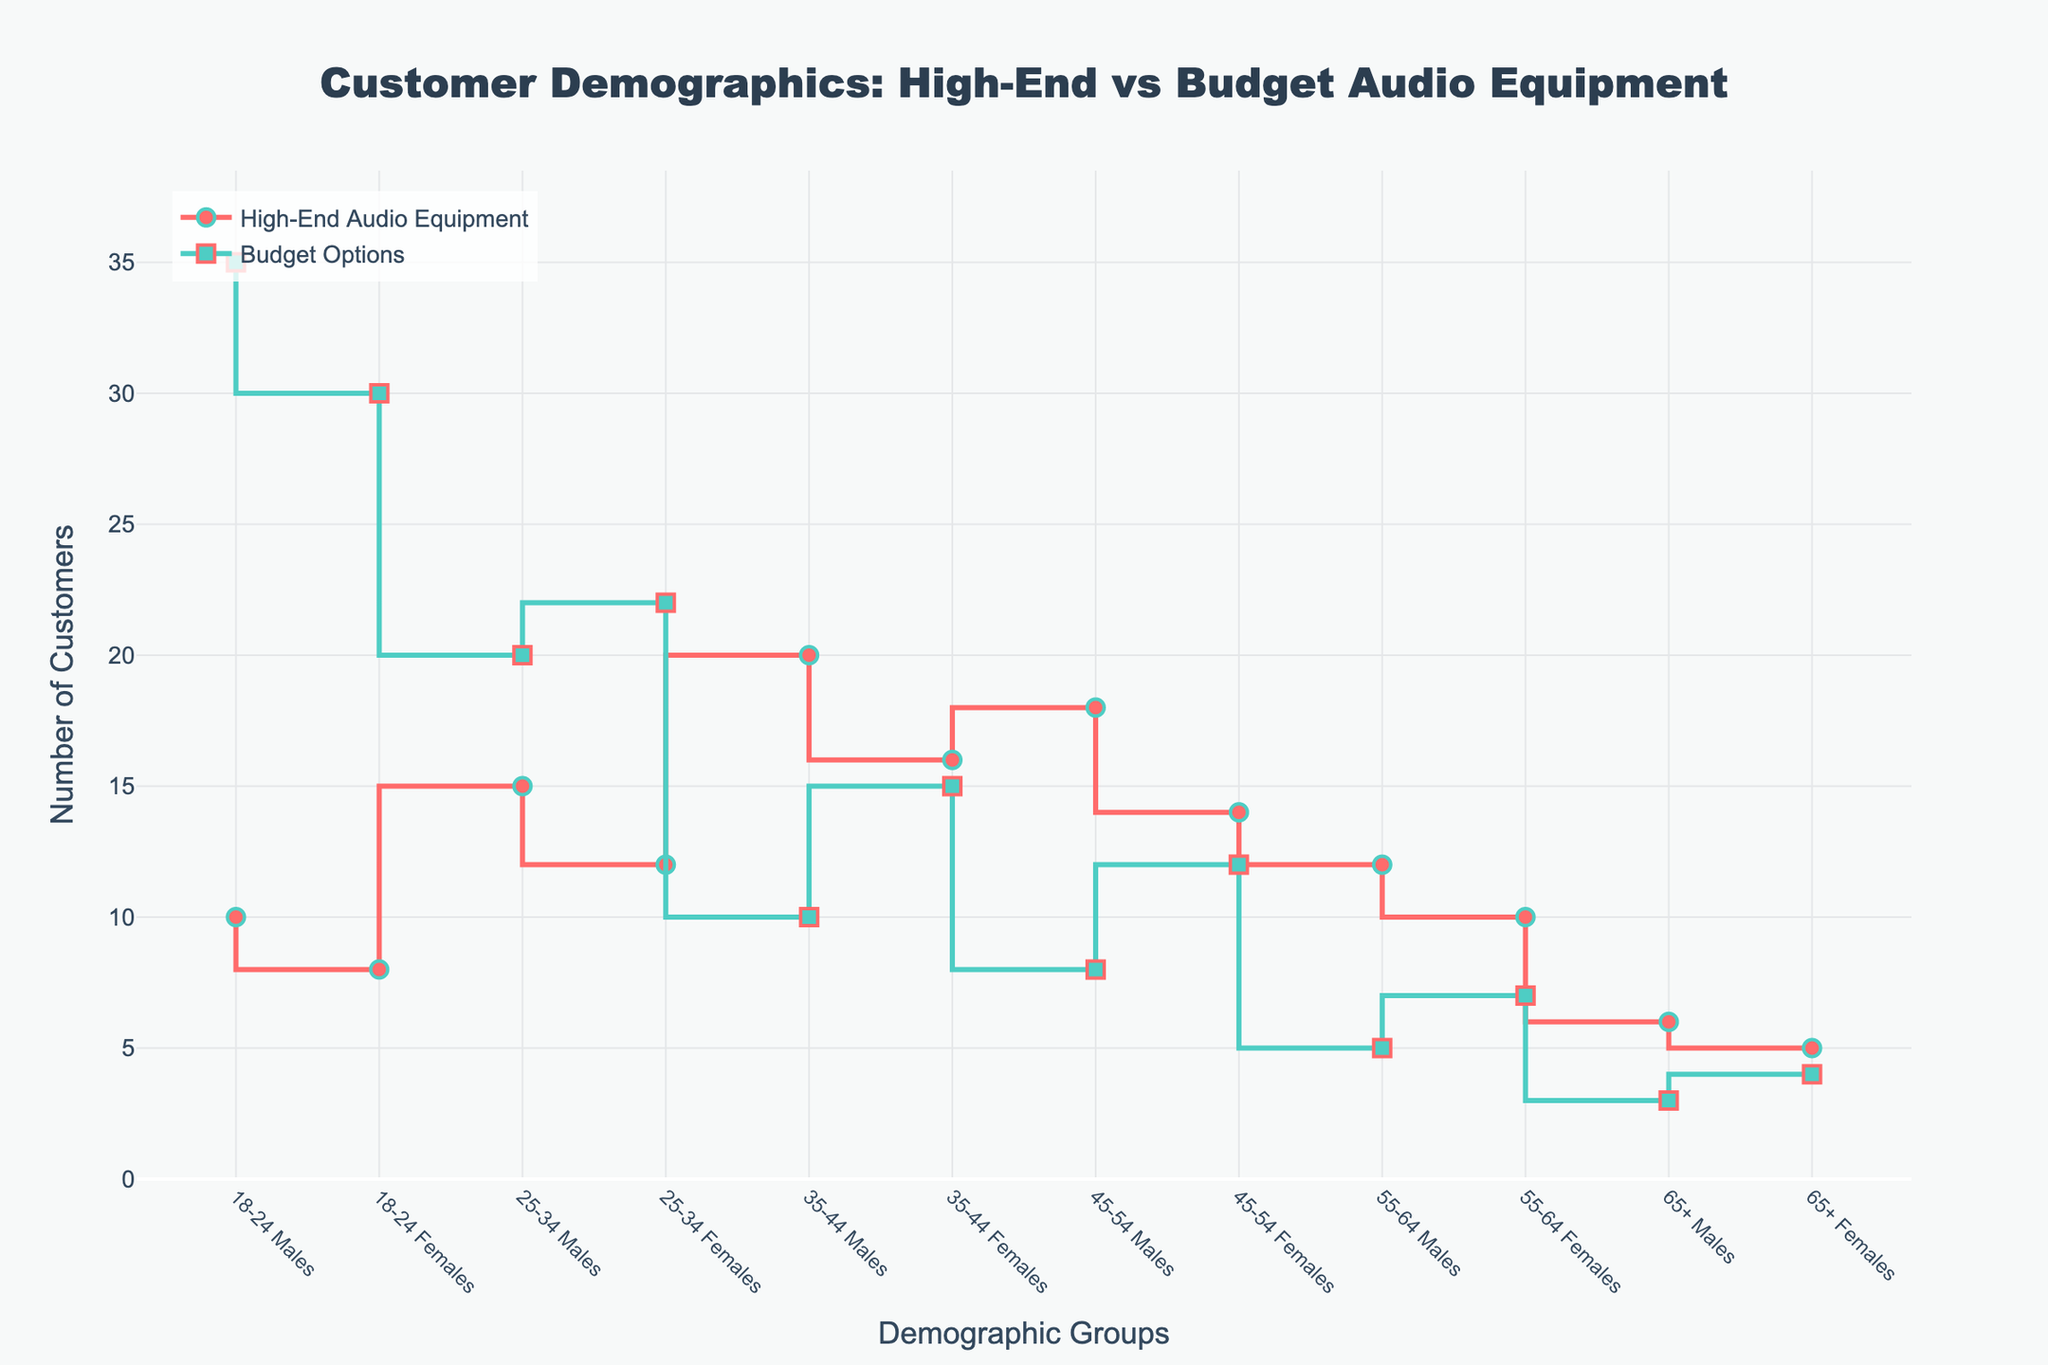What is the title of the plot? The title is located at the top center of the plot and is clearly stated.
Answer: Customer Demographics: High-End vs Budget Audio Equipment Which demographic group has the highest number of customers for budget options? By examining the budget options line, the highest value point corresponds to the demographic "18-24 Males."
Answer: 18-24 Males What is the difference in customer count between "25-34 Males" and "35-44 Females" for high-end audio equipment? The number of customers for "25-34 Males" is 15 and for "35-44 Females" is 16. The difference is the absolute value of 15 - 16.
Answer: 1 Which group has more customers aged 45-54 for high-end audio equipment: males or females? For the 45-54 age group, males have 18 customers, and females have 14 customers; hence, males have more.
Answer: Males What is the sum of the customer counts for "65+ Females" in both high-end audio equipment and budget options? Add the numbers for "65+ Females" in both categories: 5 (high-end) + 4 (budget) = 9.
Answer: 9 Which age and gender group shows a greater preference for high-end audio equipment compared to budget options? Compare the customer counts for each group. "35-44 Males" show a significant preference for high-end (20) over budget (10) options.
Answer: 35-44 Males How does the customer count for "55-64 Females" in budget options compare to "55-64 Males" in high-end audio equipment? "55-64 Females" in budget options have 7 customers, while "55-64 Males" in high-end equipment have 12 customers. Therefore, more males opt for high-end.
Answer: Males have more Is there any demographic group where high-end audio equipment and budget options have nearly equal customer counts? Evaluate each demographic group. The closest numbers are "65+ Females" with 5 for high-end and 4 for budget options.
Answer: 65+ Females What is the disparity in customer count for high-end audio equipment between the youngest and oldest male demographics? The number of customers for "18-24 Males" is 10, and for "65+ Males" is 6. The difference is 10 - 6.
Answer: 4 